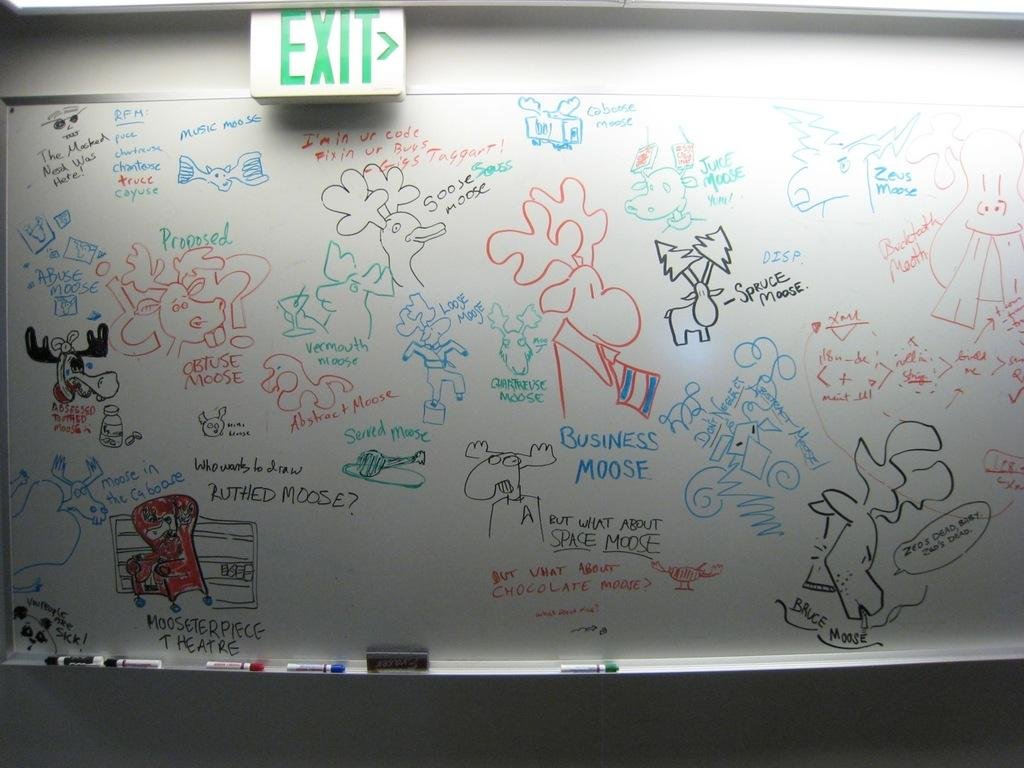<image>
Relay a brief, clear account of the picture shown. A whiteboard with several moose drawings under an EXIT sign 